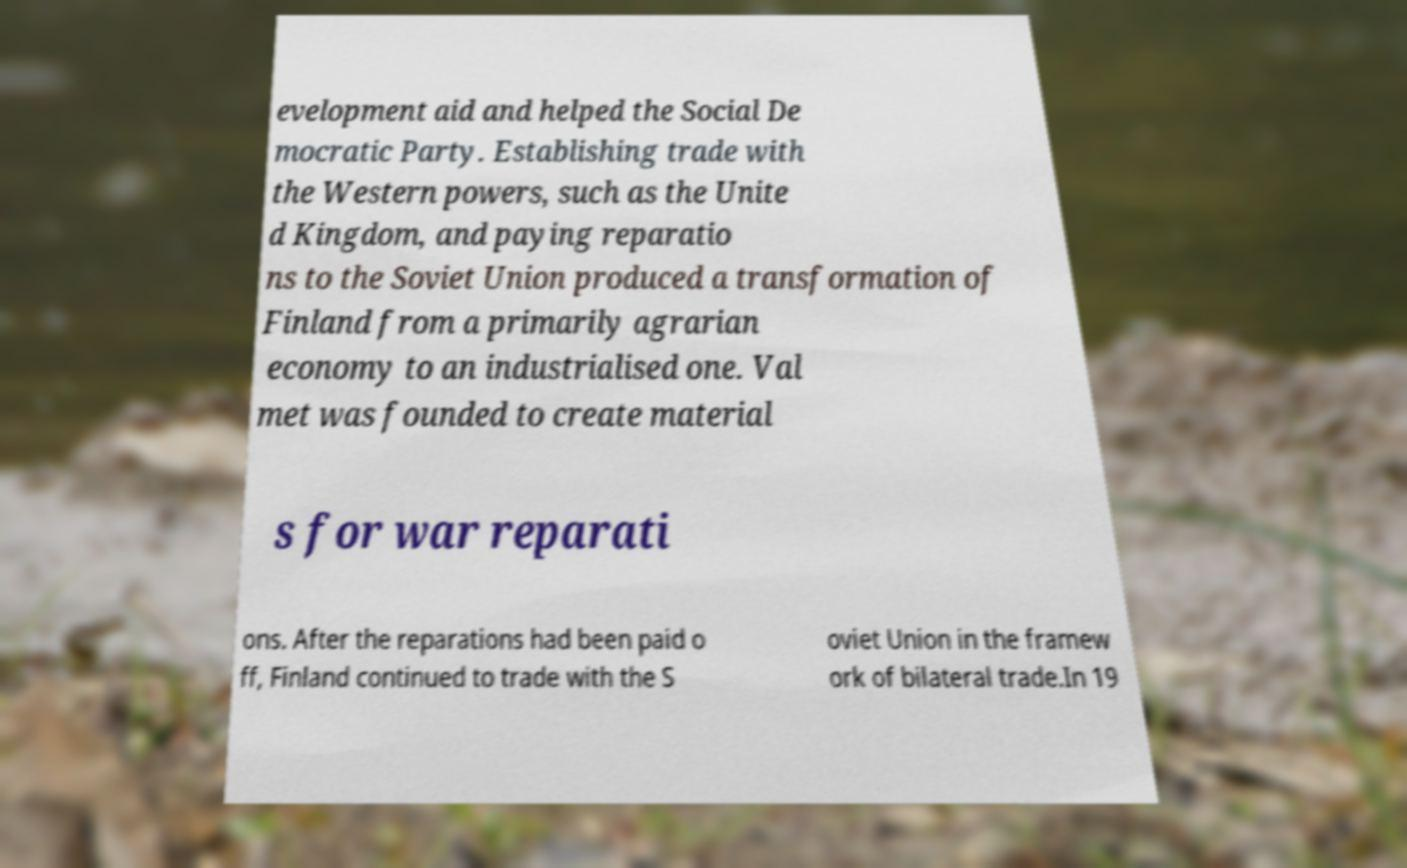Can you read and provide the text displayed in the image?This photo seems to have some interesting text. Can you extract and type it out for me? evelopment aid and helped the Social De mocratic Party. Establishing trade with the Western powers, such as the Unite d Kingdom, and paying reparatio ns to the Soviet Union produced a transformation of Finland from a primarily agrarian economy to an industrialised one. Val met was founded to create material s for war reparati ons. After the reparations had been paid o ff, Finland continued to trade with the S oviet Union in the framew ork of bilateral trade.In 19 